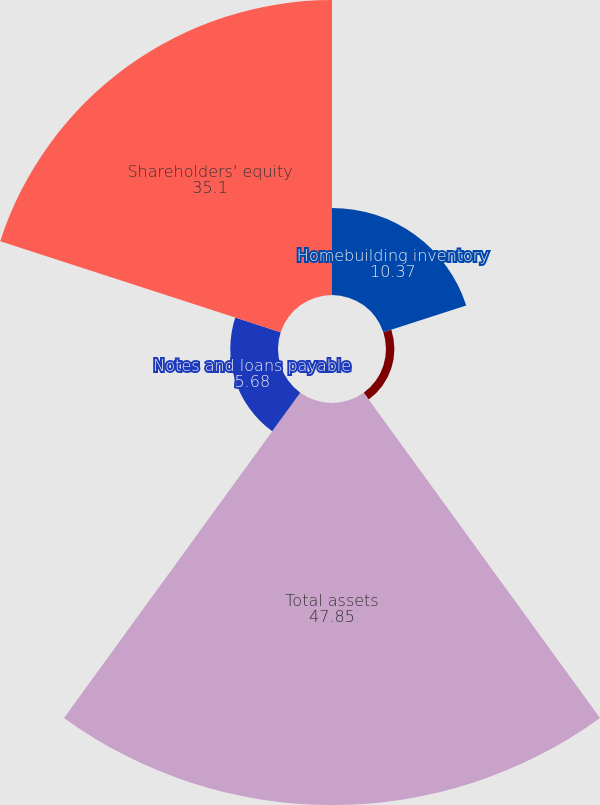Convert chart to OTSL. <chart><loc_0><loc_0><loc_500><loc_500><pie_chart><fcel>Homebuilding inventory<fcel>Contract land deposits net<fcel>Total assets<fcel>Notes and loans payable<fcel>Shareholders' equity<nl><fcel>10.37%<fcel>1.0%<fcel>47.85%<fcel>5.68%<fcel>35.1%<nl></chart> 